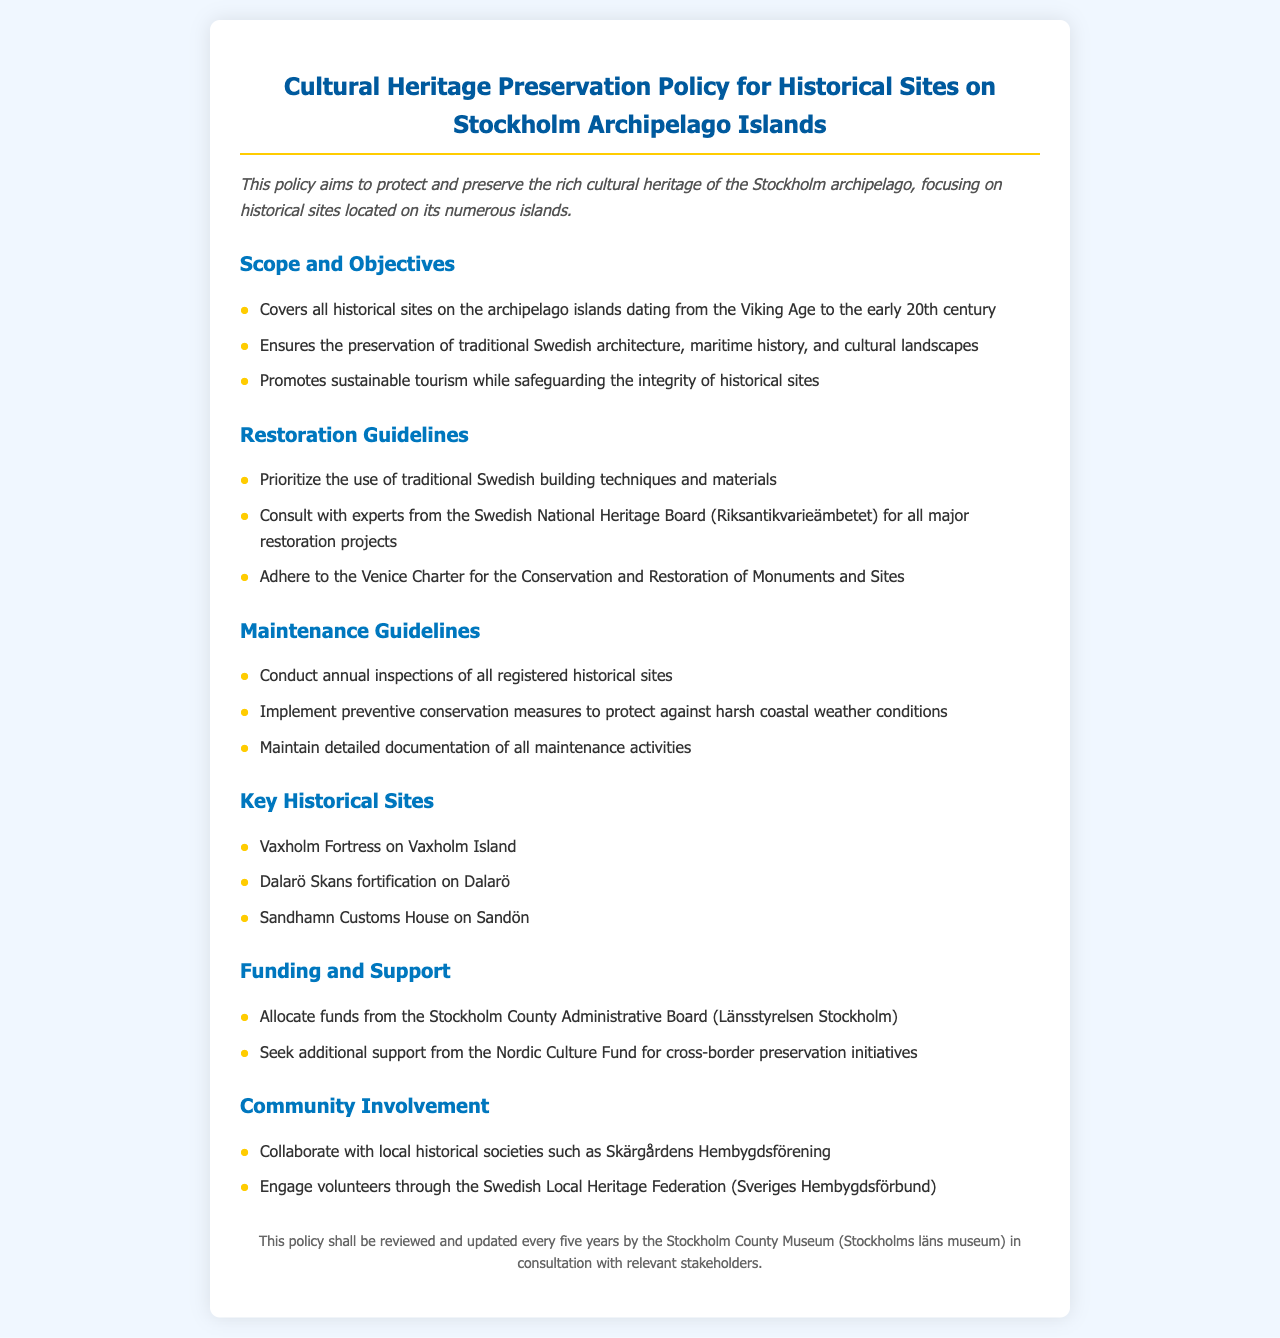What is the main aim of the policy? The main aim of the policy is to protect and preserve the rich cultural heritage of the Stockholm archipelago, focusing on historical sites located on its numerous islands.
Answer: Protect and preserve cultural heritage What historical periods does the policy cover? The policy covers all historical sites on the archipelago islands dating from the Viking Age to the early 20th century.
Answer: Viking Age to early 20th century Which charter should be adhered to during major restoration projects? The policy states that the Venice Charter for the Conservation and Restoration of Monuments and Sites should be adhered to for major restoration projects.
Answer: Venice Charter How often should annual inspections be conducted? According to the maintenance guidelines, annual inspections of all registered historical sites should be conducted.
Answer: Annual What is one of the key historical sites mentioned? The document lists specific historical sites, including Vaxholm Fortress on Vaxholm Island as one of them.
Answer: Vaxholm Fortress Which organization provides funding for cultural heritage preservation? The policy mentions that funds are allocated from the Stockholm County Administrative Board for cultural heritage preservation.
Answer: Stockholm County Administrative Board What type of weather conditions are mentioned as a concern for preventive conservation? The policy indicates that preventive conservation measures should protect against harsh coastal weather conditions.
Answer: Harsh coastal weather How often will the policy be reviewed? The document states that this policy shall be reviewed and updated every five years.
Answer: Every five years 